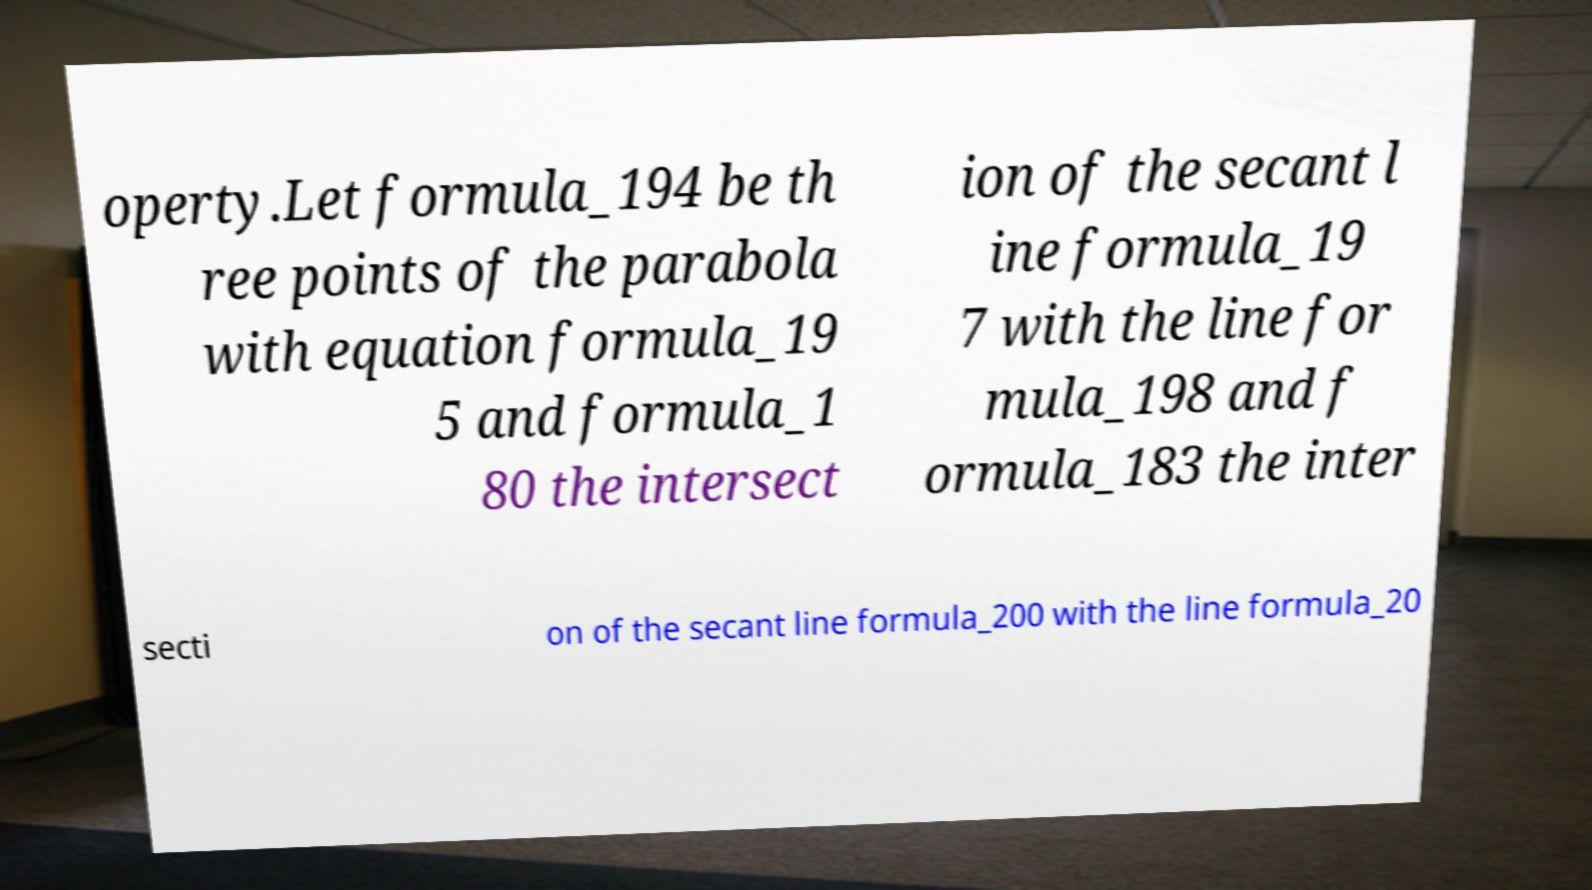Please read and relay the text visible in this image. What does it say? operty.Let formula_194 be th ree points of the parabola with equation formula_19 5 and formula_1 80 the intersect ion of the secant l ine formula_19 7 with the line for mula_198 and f ormula_183 the inter secti on of the secant line formula_200 with the line formula_20 